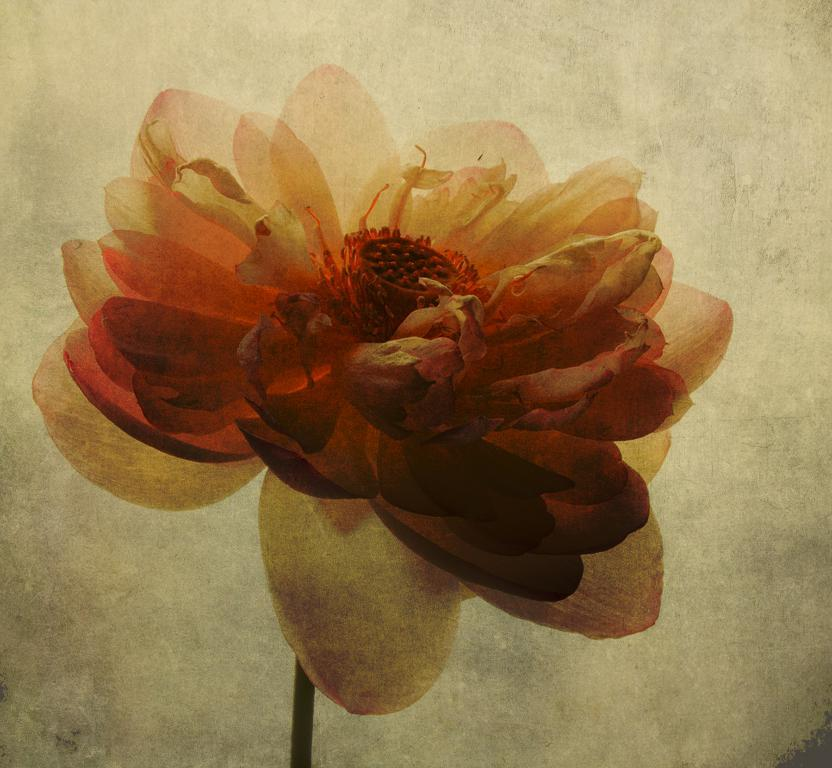What is the main subject of the image? There is a flower in the center of the image. Can you describe the flower in more detail? Unfortunately, the image does not provide enough detail to describe the flower further. Is there anything else in the image besides the flower? The provided facts do not mention any other objects or subjects in the image. How many windows can be seen in the image? There are no windows present in the image, as it only features a flower in the center. 